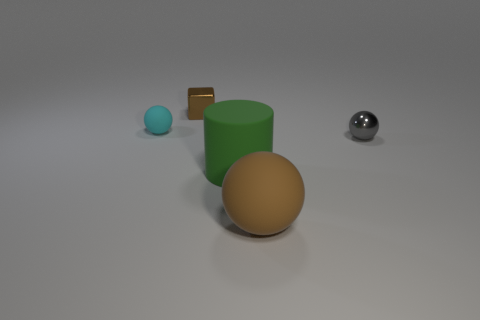Subtract all small spheres. How many spheres are left? 1 Subtract 1 cubes. How many cubes are left? 0 Add 5 gray metallic things. How many objects exist? 10 Subtract all gray balls. How many balls are left? 2 Add 2 tiny matte balls. How many tiny matte balls exist? 3 Subtract 0 gray cylinders. How many objects are left? 5 Subtract all balls. How many objects are left? 2 Subtract all yellow balls. Subtract all yellow cylinders. How many balls are left? 3 Subtract all purple balls. How many blue blocks are left? 0 Subtract all tiny gray things. Subtract all shiny blocks. How many objects are left? 3 